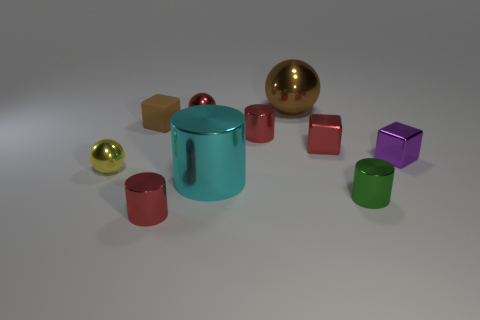Is there another sphere that has the same material as the yellow ball?
Your answer should be compact. Yes. Do the green metal cylinder and the purple metal block have the same size?
Make the answer very short. Yes. How many blocks are either big things or red shiny things?
Provide a short and direct response. 1. What material is the large sphere that is the same color as the rubber cube?
Offer a terse response. Metal. How many cyan things have the same shape as the green thing?
Provide a short and direct response. 1. Are there more red cylinders that are in front of the green metal cylinder than cyan things that are to the right of the brown metal object?
Ensure brevity in your answer.  Yes. Does the block that is right of the small green metallic thing have the same color as the rubber thing?
Offer a terse response. No. The red metallic block has what size?
Provide a short and direct response. Small. There is a brown thing that is the same size as the cyan metal cylinder; what is it made of?
Your answer should be very brief. Metal. There is a small metal cylinder behind the red shiny block; what is its color?
Offer a very short reply. Red. 